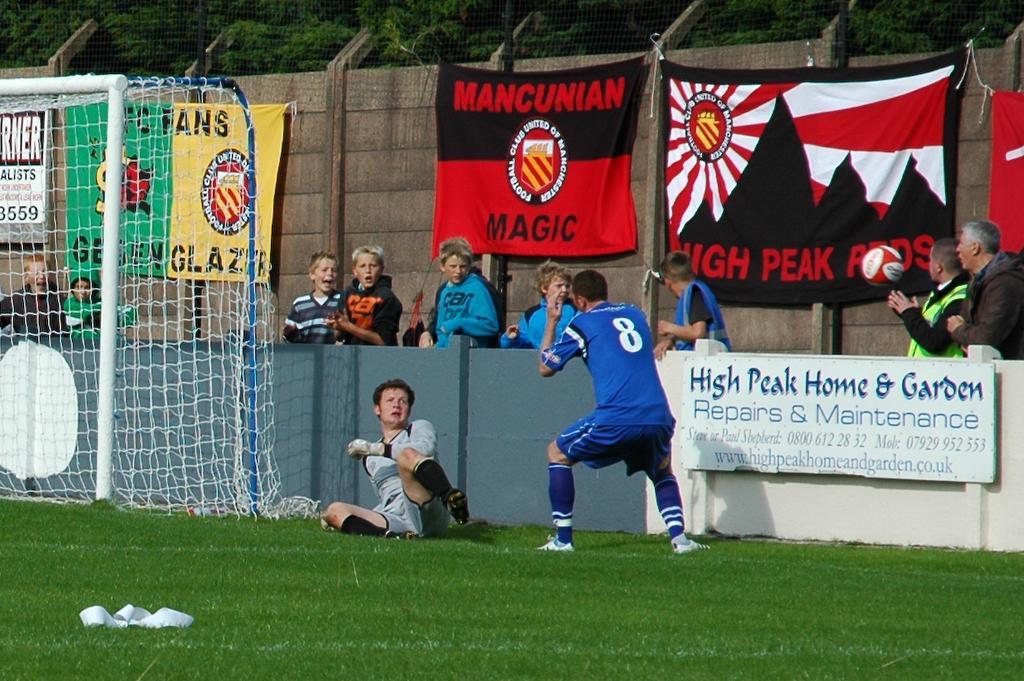Can you describe this image briefly? In the foreground of the picture there is a ground covered with grass. On the left there is a goal post. In the middle of the picture there are players and wall, beside the wall there are people. In the background there are trees, flags, wall. 